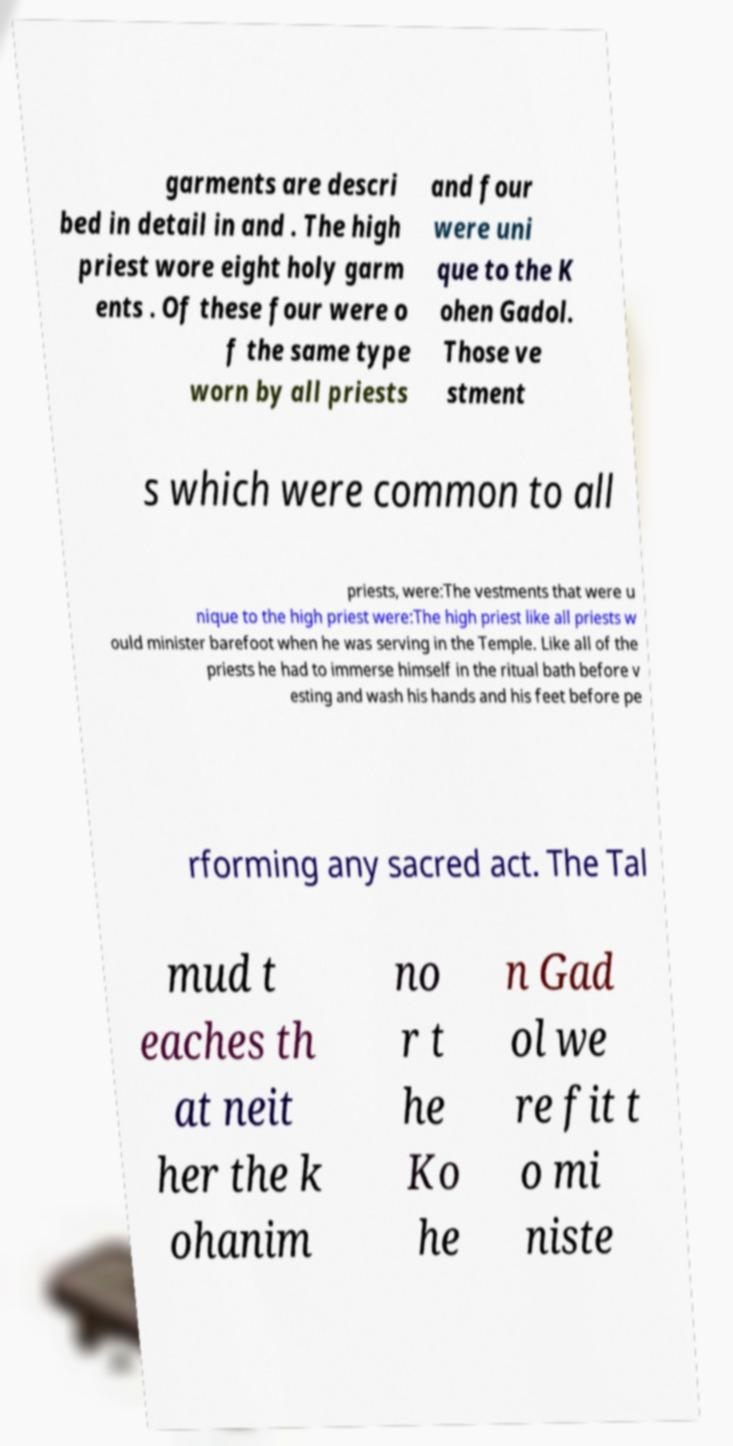Please identify and transcribe the text found in this image. garments are descri bed in detail in and . The high priest wore eight holy garm ents . Of these four were o f the same type worn by all priests and four were uni que to the K ohen Gadol. Those ve stment s which were common to all priests, were:The vestments that were u nique to the high priest were:The high priest like all priests w ould minister barefoot when he was serving in the Temple. Like all of the priests he had to immerse himself in the ritual bath before v esting and wash his hands and his feet before pe rforming any sacred act. The Tal mud t eaches th at neit her the k ohanim no r t he Ko he n Gad ol we re fit t o mi niste 